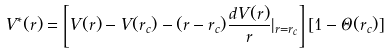<formula> <loc_0><loc_0><loc_500><loc_500>V ^ { * } ( r ) = \left [ V ( r ) - V ( r _ { c } ) - ( r - r _ { c } ) \frac { d V ( r ) } { r } | _ { r = r _ { c } } \right ] [ 1 - \Theta ( r _ { c } ) ]</formula> 